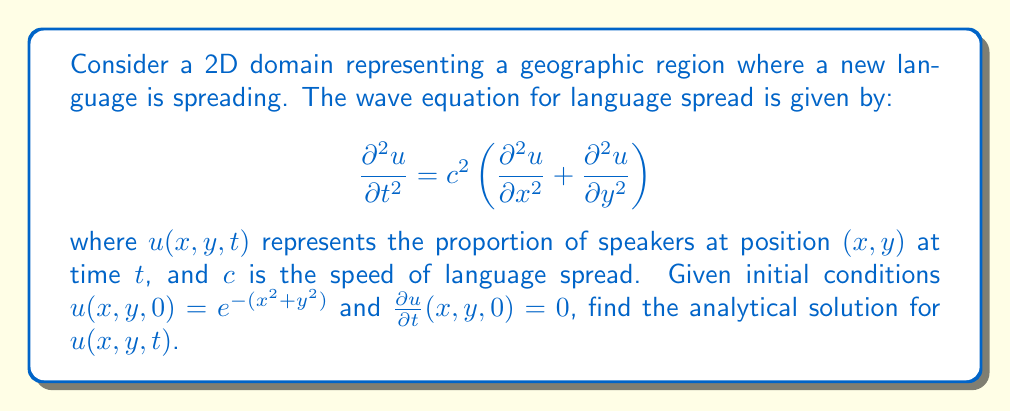Provide a solution to this math problem. To solve this problem, we'll follow these steps:

1) The general solution for the 2D wave equation with radial symmetry is:

   $$u(r,t) = \frac{1}{2ct}\int_0^{2\pi} f(r + ct\cos\theta) d\theta$$

   where $r = \sqrt{x^2 + y^2}$ and $f(r)$ is the initial condition.

2) In our case, $f(r) = e^{-r^2}$ and the initial velocity is zero.

3) Substituting this into the general solution:

   $$u(r,t) = \frac{1}{2ct}\int_0^{2\pi} e^{-(r + ct\cos\theta)^2} d\theta$$

4) This integral can be simplified using the modified Bessel function of the first kind, $I_0$:

   $$u(r,t) = e^{-(r^2 + c^2t^2)} I_0(2rct)$$

5) Converting back to Cartesian coordinates:

   $$u(x,y,t) = e^{-(x^2 + y^2 + c^2t^2)} I_0(2ct\sqrt{x^2 + y^2})$$

This is the analytical solution for the language spread pattern in the given 2D domain.
Answer: $u(x,y,t) = e^{-(x^2 + y^2 + c^2t^2)} I_0(2ct\sqrt{x^2 + y^2})$ 